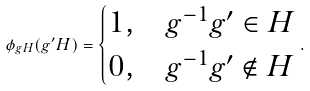<formula> <loc_0><loc_0><loc_500><loc_500>\phi _ { g H } ( g ^ { \prime } H ) = \begin{cases} 1 , & g ^ { - 1 } g ^ { \prime } \in H \\ 0 , & g ^ { - 1 } g ^ { \prime } \notin H \end{cases} .</formula> 